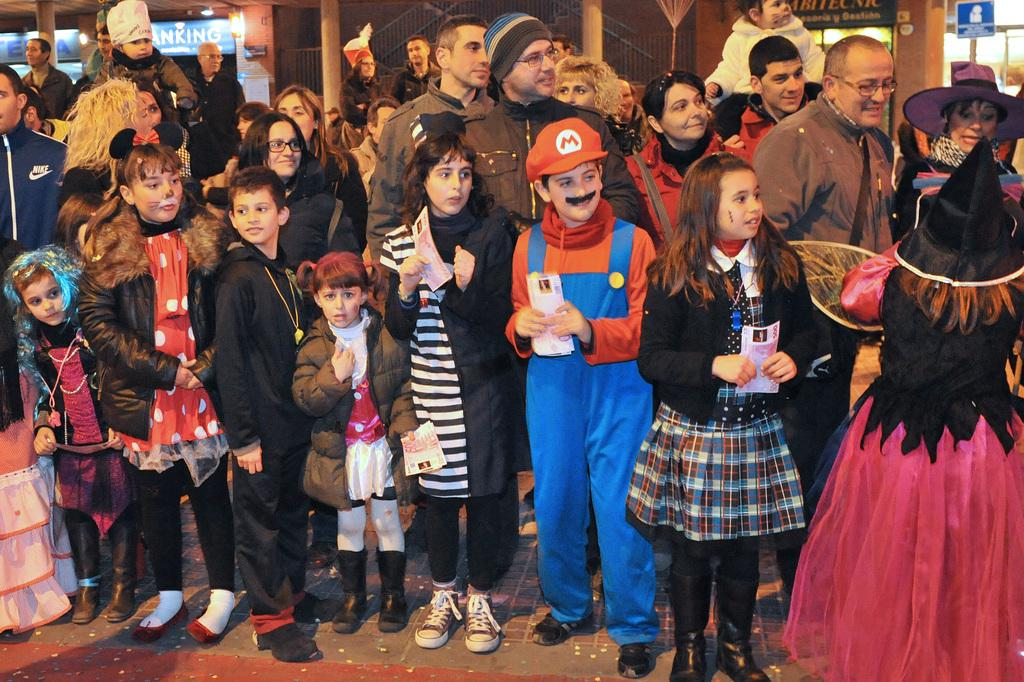How many people are in the image? There are multiple persons in the image. What are the persons wearing? The persons are wearing different costumes. What are the persons doing in the image? The persons are standing. What can be seen in the background of the image? There are pillars and a wall in the background of the image. How far away is the worm from the chin in the image? There is no worm or chin present in the image. 